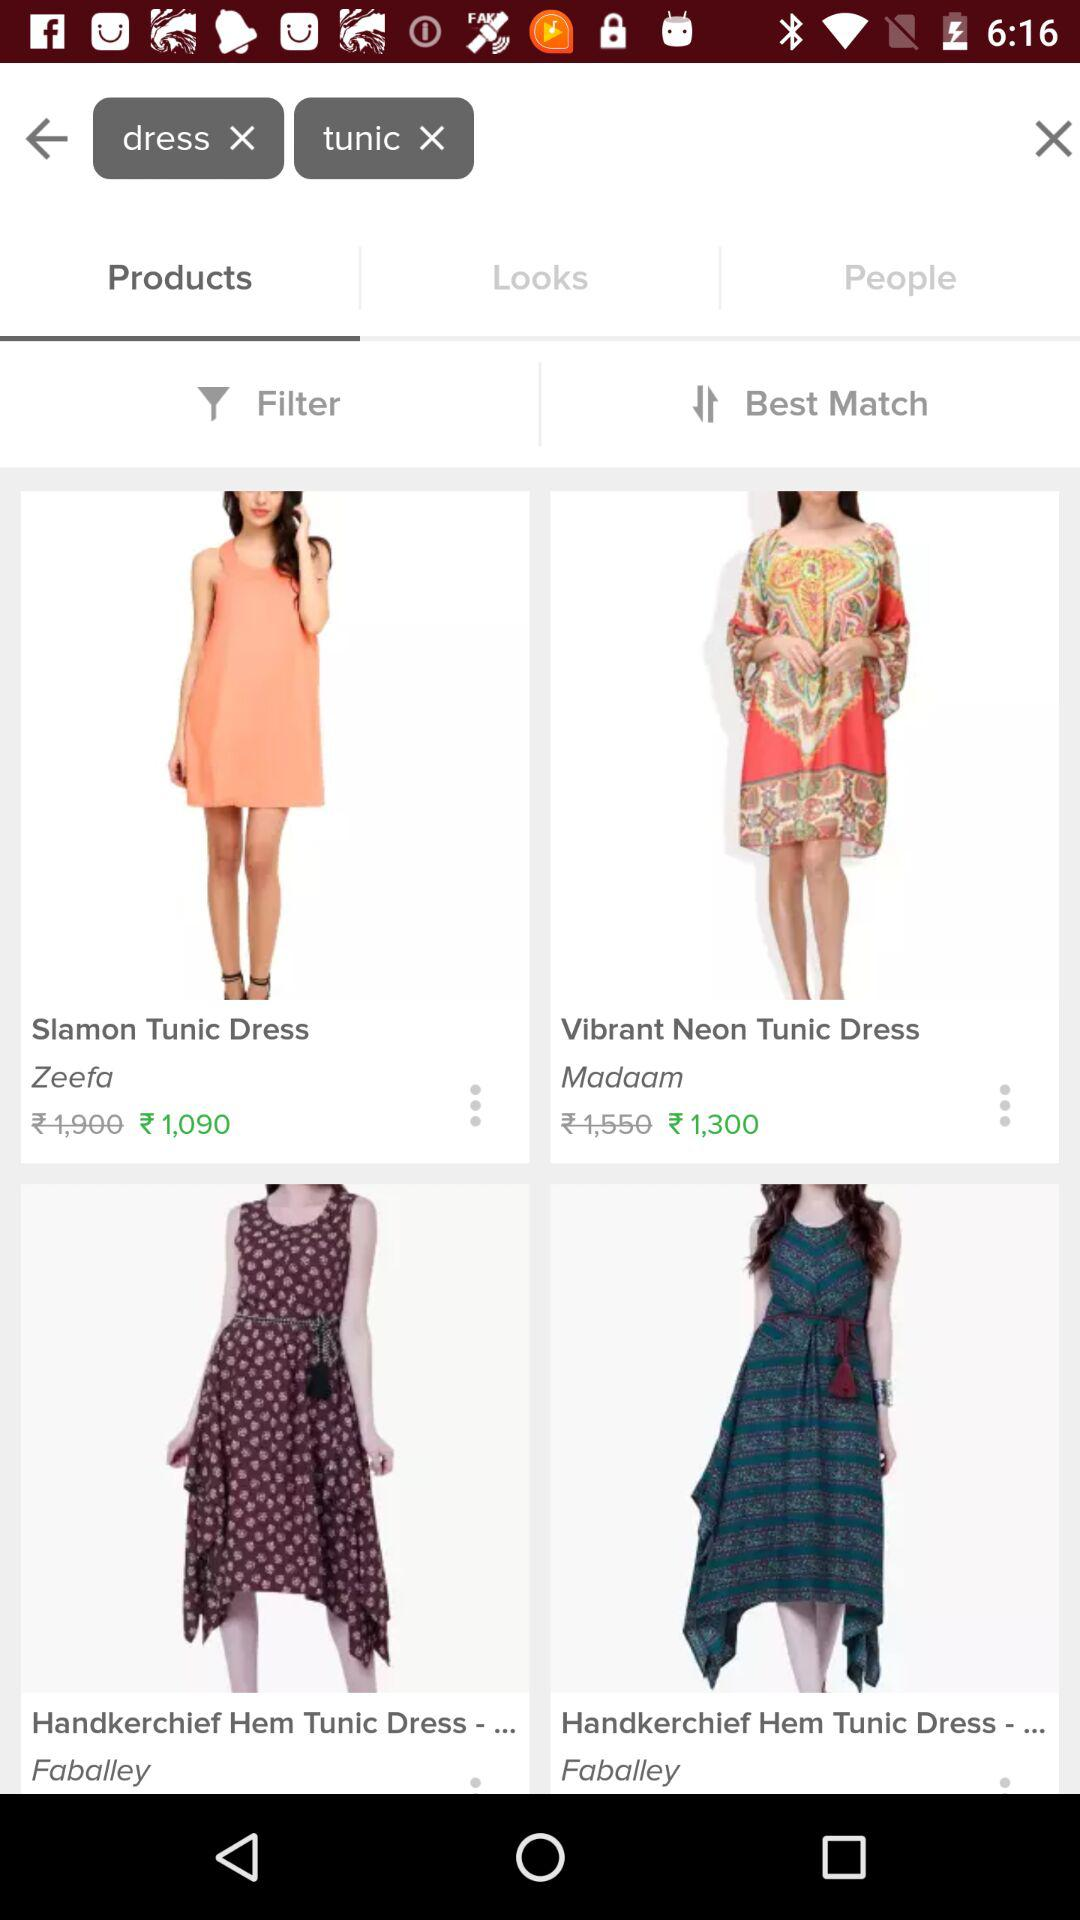What is the brand name of the neon tunic dress? The brand name of the neon tunic dress is "Madaam". 